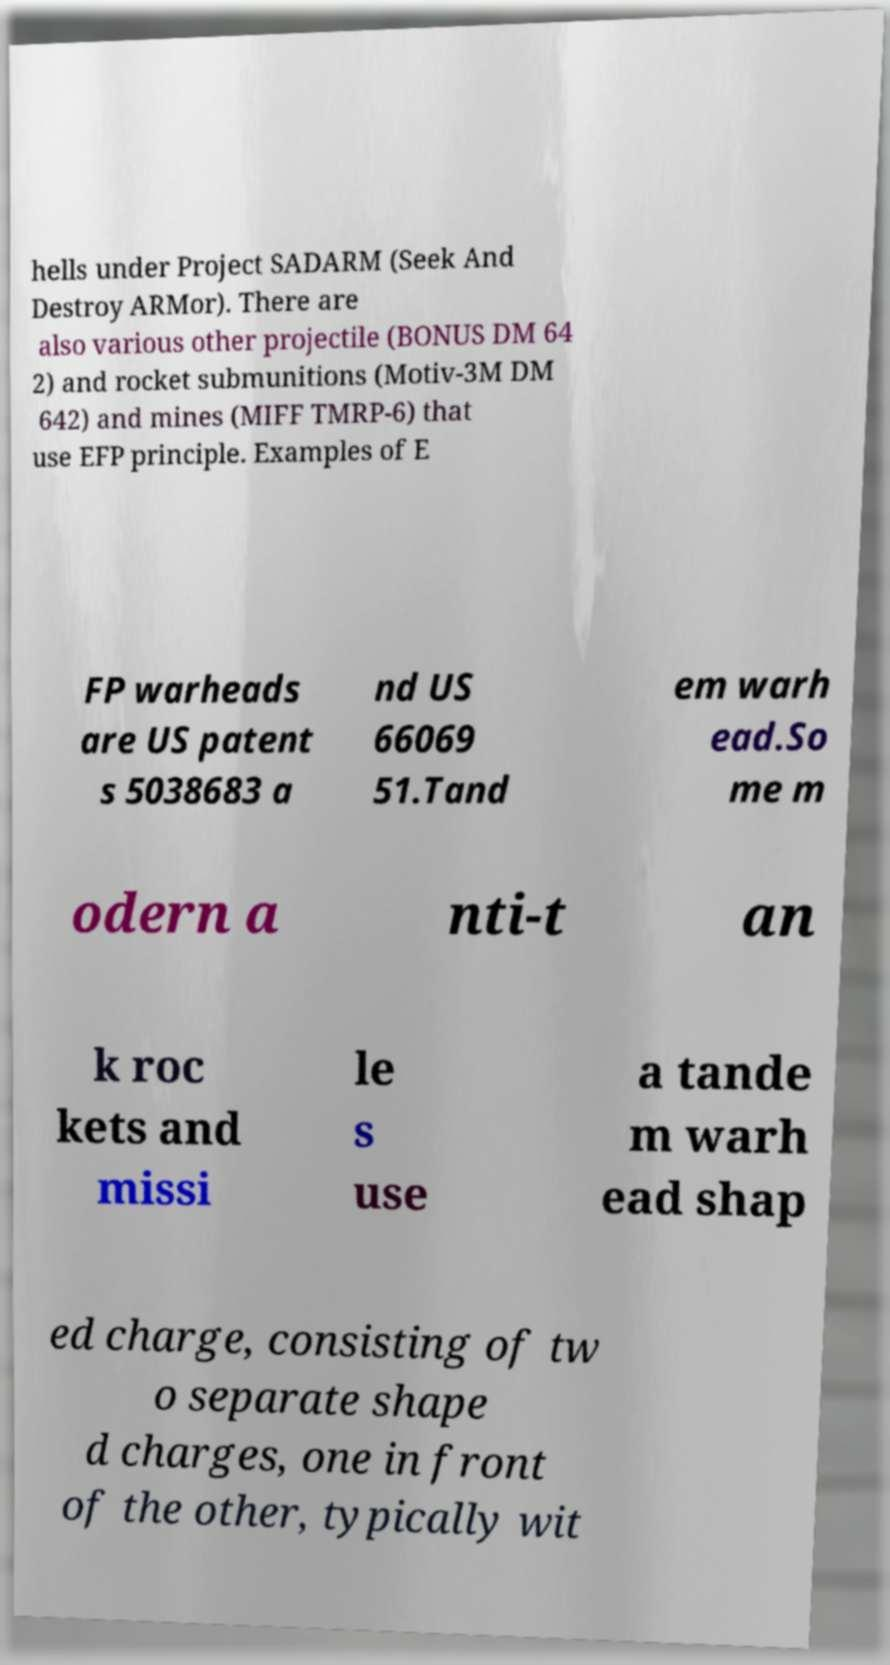For documentation purposes, I need the text within this image transcribed. Could you provide that? hells under Project SADARM (Seek And Destroy ARMor). There are also various other projectile (BONUS DM 64 2) and rocket submunitions (Motiv-3M DM 642) and mines (MIFF TMRP-6) that use EFP principle. Examples of E FP warheads are US patent s 5038683 a nd US 66069 51.Tand em warh ead.So me m odern a nti-t an k roc kets and missi le s use a tande m warh ead shap ed charge, consisting of tw o separate shape d charges, one in front of the other, typically wit 